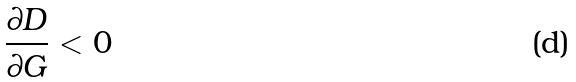<formula> <loc_0><loc_0><loc_500><loc_500>\frac { \partial D } { \partial G } < 0</formula> 